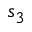<formula> <loc_0><loc_0><loc_500><loc_500>s _ { 3 }</formula> 